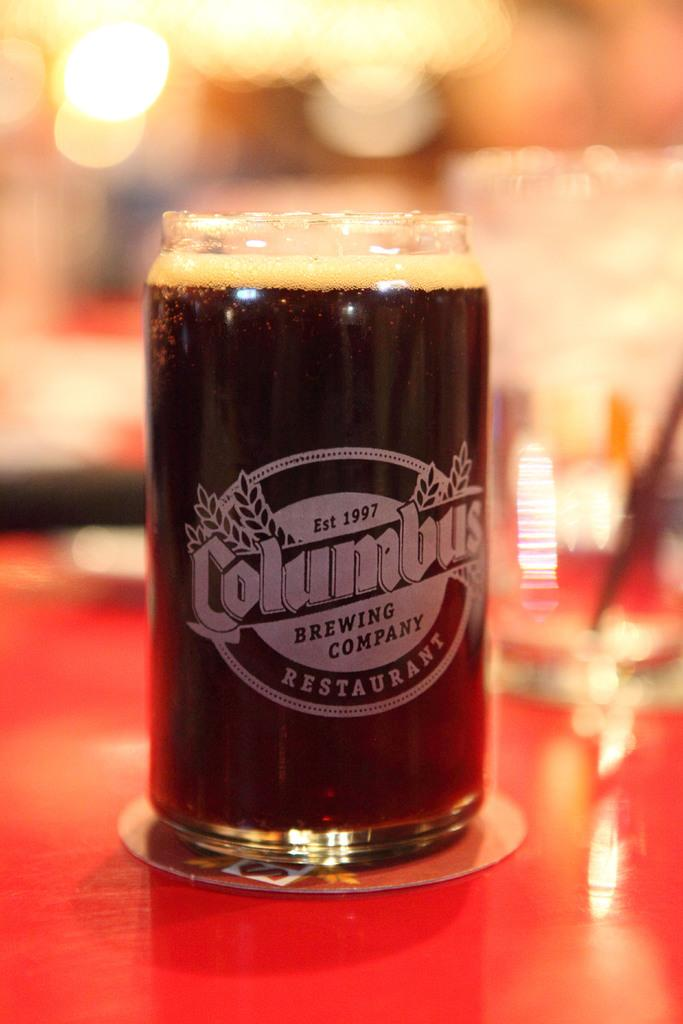<image>
Give a short and clear explanation of the subsequent image. A drinking glass from Columbus brewing company restaurant is full of liquid. 